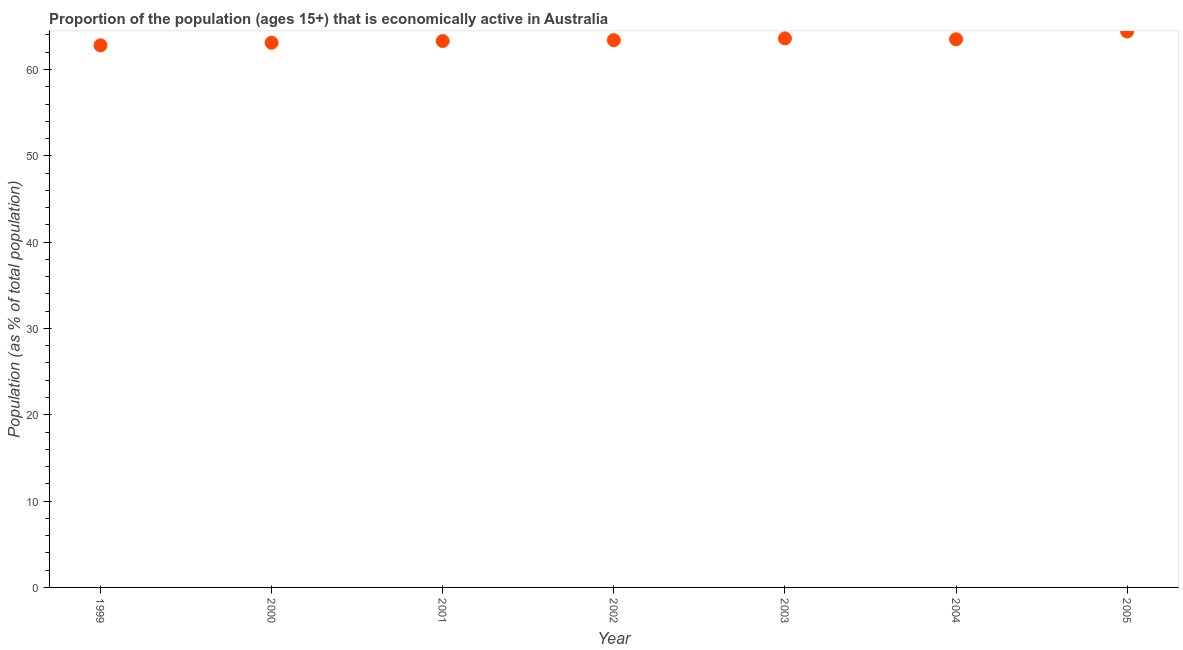What is the percentage of economically active population in 2004?
Provide a succinct answer. 63.5. Across all years, what is the maximum percentage of economically active population?
Ensure brevity in your answer.  64.4. Across all years, what is the minimum percentage of economically active population?
Your answer should be compact. 62.8. In which year was the percentage of economically active population minimum?
Your answer should be compact. 1999. What is the sum of the percentage of economically active population?
Ensure brevity in your answer.  444.1. What is the average percentage of economically active population per year?
Provide a short and direct response. 63.44. What is the median percentage of economically active population?
Offer a terse response. 63.4. In how many years, is the percentage of economically active population greater than 22 %?
Provide a succinct answer. 7. Do a majority of the years between 2000 and 2004 (inclusive) have percentage of economically active population greater than 20 %?
Give a very brief answer. Yes. What is the ratio of the percentage of economically active population in 2001 to that in 2005?
Your answer should be compact. 0.98. What is the difference between the highest and the second highest percentage of economically active population?
Your response must be concise. 0.8. What is the difference between the highest and the lowest percentage of economically active population?
Your answer should be compact. 1.6. In how many years, is the percentage of economically active population greater than the average percentage of economically active population taken over all years?
Keep it short and to the point. 3. Does the percentage of economically active population monotonically increase over the years?
Give a very brief answer. No. How many dotlines are there?
Offer a terse response. 1. How many years are there in the graph?
Provide a short and direct response. 7. What is the difference between two consecutive major ticks on the Y-axis?
Your answer should be compact. 10. Are the values on the major ticks of Y-axis written in scientific E-notation?
Your answer should be very brief. No. Does the graph contain grids?
Provide a succinct answer. No. What is the title of the graph?
Your answer should be compact. Proportion of the population (ages 15+) that is economically active in Australia. What is the label or title of the X-axis?
Provide a short and direct response. Year. What is the label or title of the Y-axis?
Keep it short and to the point. Population (as % of total population). What is the Population (as % of total population) in 1999?
Your response must be concise. 62.8. What is the Population (as % of total population) in 2000?
Keep it short and to the point. 63.1. What is the Population (as % of total population) in 2001?
Your answer should be very brief. 63.3. What is the Population (as % of total population) in 2002?
Provide a succinct answer. 63.4. What is the Population (as % of total population) in 2003?
Provide a short and direct response. 63.6. What is the Population (as % of total population) in 2004?
Keep it short and to the point. 63.5. What is the Population (as % of total population) in 2005?
Offer a terse response. 64.4. What is the difference between the Population (as % of total population) in 1999 and 2000?
Offer a terse response. -0.3. What is the difference between the Population (as % of total population) in 1999 and 2001?
Your answer should be compact. -0.5. What is the difference between the Population (as % of total population) in 1999 and 2004?
Make the answer very short. -0.7. What is the difference between the Population (as % of total population) in 1999 and 2005?
Offer a very short reply. -1.6. What is the difference between the Population (as % of total population) in 2000 and 2001?
Give a very brief answer. -0.2. What is the difference between the Population (as % of total population) in 2000 and 2002?
Offer a terse response. -0.3. What is the difference between the Population (as % of total population) in 2000 and 2003?
Provide a succinct answer. -0.5. What is the difference between the Population (as % of total population) in 2000 and 2004?
Make the answer very short. -0.4. What is the difference between the Population (as % of total population) in 2001 and 2003?
Your answer should be compact. -0.3. What is the difference between the Population (as % of total population) in 2001 and 2005?
Offer a very short reply. -1.1. What is the difference between the Population (as % of total population) in 2002 and 2003?
Make the answer very short. -0.2. What is the difference between the Population (as % of total population) in 2002 and 2005?
Give a very brief answer. -1. What is the difference between the Population (as % of total population) in 2003 and 2004?
Provide a succinct answer. 0.1. What is the difference between the Population (as % of total population) in 2003 and 2005?
Provide a short and direct response. -0.8. What is the difference between the Population (as % of total population) in 2004 and 2005?
Keep it short and to the point. -0.9. What is the ratio of the Population (as % of total population) in 1999 to that in 2000?
Your answer should be very brief. 0.99. What is the ratio of the Population (as % of total population) in 1999 to that in 2001?
Your answer should be very brief. 0.99. What is the ratio of the Population (as % of total population) in 1999 to that in 2004?
Your answer should be compact. 0.99. What is the ratio of the Population (as % of total population) in 1999 to that in 2005?
Offer a terse response. 0.97. What is the ratio of the Population (as % of total population) in 2000 to that in 2001?
Keep it short and to the point. 1. What is the ratio of the Population (as % of total population) in 2000 to that in 2004?
Make the answer very short. 0.99. What is the ratio of the Population (as % of total population) in 2001 to that in 2003?
Your answer should be compact. 0.99. What is the ratio of the Population (as % of total population) in 2001 to that in 2004?
Provide a short and direct response. 1. What is the ratio of the Population (as % of total population) in 2002 to that in 2004?
Your response must be concise. 1. What is the ratio of the Population (as % of total population) in 2002 to that in 2005?
Make the answer very short. 0.98. What is the ratio of the Population (as % of total population) in 2003 to that in 2005?
Give a very brief answer. 0.99. What is the ratio of the Population (as % of total population) in 2004 to that in 2005?
Provide a succinct answer. 0.99. 